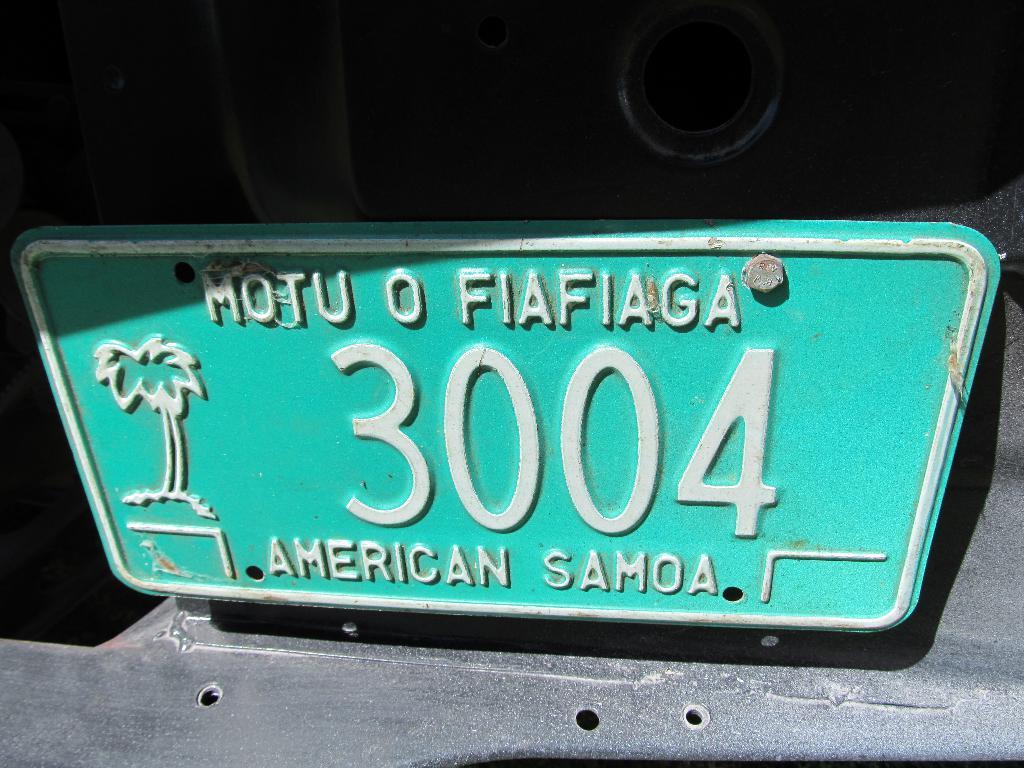What american overseas territory is named on this number plate?
Keep it short and to the point. American samoa. 